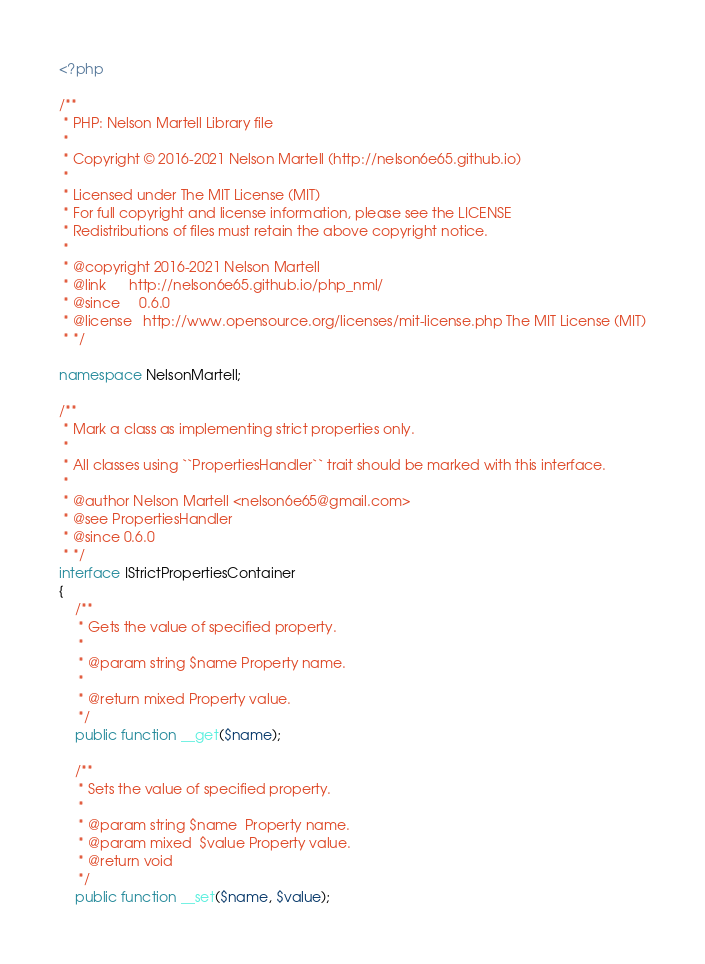<code> <loc_0><loc_0><loc_500><loc_500><_PHP_><?php

/**
 * PHP: Nelson Martell Library file
 *
 * Copyright © 2016-2021 Nelson Martell (http://nelson6e65.github.io)
 *
 * Licensed under The MIT License (MIT)
 * For full copyright and license information, please see the LICENSE
 * Redistributions of files must retain the above copyright notice.
 *
 * @copyright 2016-2021 Nelson Martell
 * @link      http://nelson6e65.github.io/php_nml/
 * @since     0.6.0
 * @license   http://www.opensource.org/licenses/mit-license.php The MIT License (MIT)
 * */

namespace NelsonMartell;

/**
 * Mark a class as implementing strict properties only.
 *
 * All classes using ``PropertiesHandler`` trait should be marked with this interface.
 *
 * @author Nelson Martell <nelson6e65@gmail.com>
 * @see PropertiesHandler
 * @since 0.6.0
 * */
interface IStrictPropertiesContainer
{
    /**
     * Gets the value of specified property.
     *
     * @param string $name Property name.
     *
     * @return mixed Property value.
     */
    public function __get($name);

    /**
     * Sets the value of specified property.
     *
     * @param string $name  Property name.
     * @param mixed  $value Property value.
     * @return void
     */
    public function __set($name, $value);</code> 